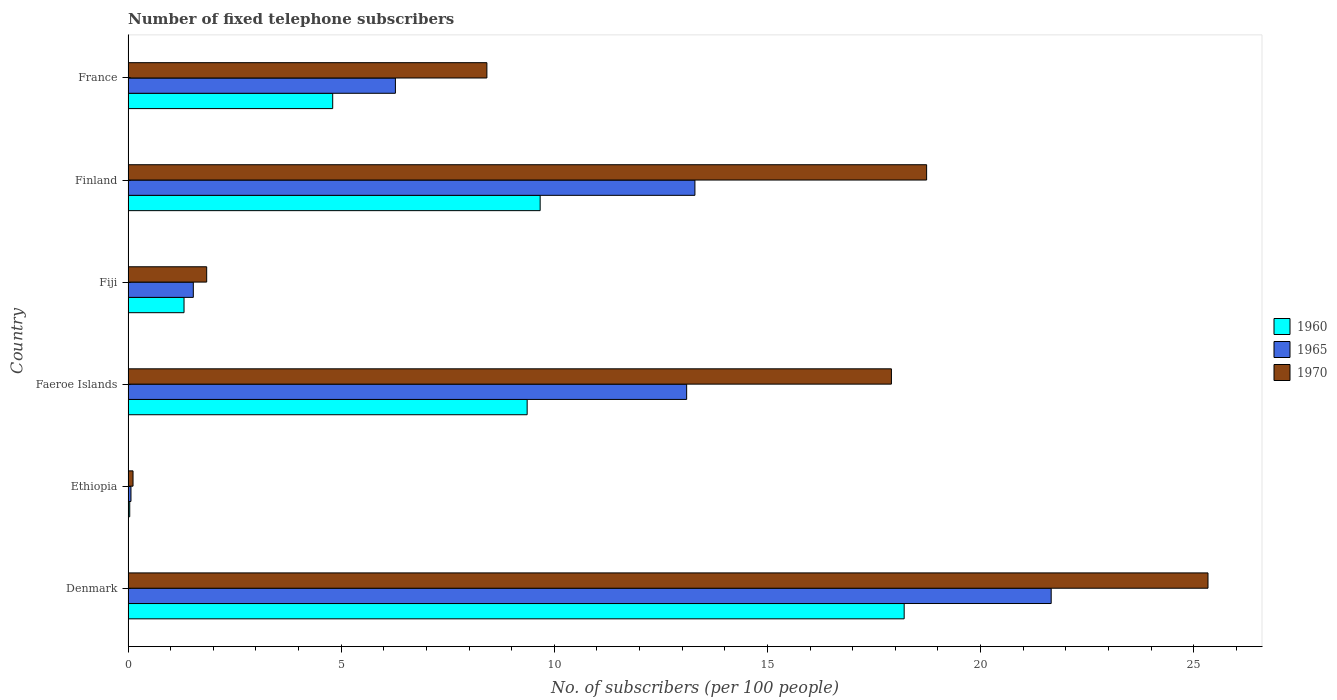How many different coloured bars are there?
Your answer should be very brief. 3. How many groups of bars are there?
Make the answer very short. 6. How many bars are there on the 4th tick from the bottom?
Your answer should be compact. 3. What is the label of the 1st group of bars from the top?
Ensure brevity in your answer.  France. What is the number of fixed telephone subscribers in 1965 in Denmark?
Provide a short and direct response. 21.66. Across all countries, what is the maximum number of fixed telephone subscribers in 1965?
Offer a terse response. 21.66. Across all countries, what is the minimum number of fixed telephone subscribers in 1965?
Your response must be concise. 0.07. In which country was the number of fixed telephone subscribers in 1965 minimum?
Provide a short and direct response. Ethiopia. What is the total number of fixed telephone subscribers in 1970 in the graph?
Ensure brevity in your answer.  72.35. What is the difference between the number of fixed telephone subscribers in 1960 in Finland and that in France?
Make the answer very short. 4.87. What is the difference between the number of fixed telephone subscribers in 1970 in France and the number of fixed telephone subscribers in 1965 in Finland?
Your answer should be very brief. -4.88. What is the average number of fixed telephone subscribers in 1965 per country?
Your answer should be very brief. 9.32. What is the difference between the number of fixed telephone subscribers in 1965 and number of fixed telephone subscribers in 1960 in Finland?
Ensure brevity in your answer.  3.63. What is the ratio of the number of fixed telephone subscribers in 1960 in Fiji to that in France?
Keep it short and to the point. 0.27. Is the difference between the number of fixed telephone subscribers in 1965 in Denmark and Finland greater than the difference between the number of fixed telephone subscribers in 1960 in Denmark and Finland?
Keep it short and to the point. No. What is the difference between the highest and the second highest number of fixed telephone subscribers in 1965?
Offer a terse response. 8.36. What is the difference between the highest and the lowest number of fixed telephone subscribers in 1965?
Offer a terse response. 21.59. In how many countries, is the number of fixed telephone subscribers in 1970 greater than the average number of fixed telephone subscribers in 1970 taken over all countries?
Ensure brevity in your answer.  3. What does the 2nd bar from the top in Fiji represents?
Keep it short and to the point. 1965. What does the 2nd bar from the bottom in Faeroe Islands represents?
Your response must be concise. 1965. How many countries are there in the graph?
Make the answer very short. 6. What is the difference between two consecutive major ticks on the X-axis?
Offer a very short reply. 5. Are the values on the major ticks of X-axis written in scientific E-notation?
Provide a short and direct response. No. Does the graph contain any zero values?
Your answer should be compact. No. Where does the legend appear in the graph?
Provide a succinct answer. Center right. How many legend labels are there?
Your answer should be compact. 3. What is the title of the graph?
Your answer should be very brief. Number of fixed telephone subscribers. Does "1981" appear as one of the legend labels in the graph?
Keep it short and to the point. No. What is the label or title of the X-axis?
Your answer should be compact. No. of subscribers (per 100 people). What is the No. of subscribers (per 100 people) in 1960 in Denmark?
Give a very brief answer. 18.21. What is the No. of subscribers (per 100 people) in 1965 in Denmark?
Provide a short and direct response. 21.66. What is the No. of subscribers (per 100 people) of 1970 in Denmark?
Your response must be concise. 25.33. What is the No. of subscribers (per 100 people) of 1960 in Ethiopia?
Offer a very short reply. 0.04. What is the No. of subscribers (per 100 people) of 1965 in Ethiopia?
Provide a succinct answer. 0.07. What is the No. of subscribers (per 100 people) of 1970 in Ethiopia?
Ensure brevity in your answer.  0.12. What is the No. of subscribers (per 100 people) of 1960 in Faeroe Islands?
Your answer should be compact. 9.36. What is the No. of subscribers (per 100 people) in 1965 in Faeroe Islands?
Make the answer very short. 13.1. What is the No. of subscribers (per 100 people) of 1970 in Faeroe Islands?
Keep it short and to the point. 17.91. What is the No. of subscribers (per 100 people) of 1960 in Fiji?
Your answer should be very brief. 1.31. What is the No. of subscribers (per 100 people) in 1965 in Fiji?
Ensure brevity in your answer.  1.53. What is the No. of subscribers (per 100 people) of 1970 in Fiji?
Make the answer very short. 1.84. What is the No. of subscribers (per 100 people) of 1960 in Finland?
Make the answer very short. 9.67. What is the No. of subscribers (per 100 people) in 1965 in Finland?
Your answer should be very brief. 13.3. What is the No. of subscribers (per 100 people) in 1970 in Finland?
Provide a succinct answer. 18.73. What is the No. of subscribers (per 100 people) of 1960 in France?
Your answer should be compact. 4.8. What is the No. of subscribers (per 100 people) of 1965 in France?
Offer a very short reply. 6.27. What is the No. of subscribers (per 100 people) of 1970 in France?
Offer a very short reply. 8.42. Across all countries, what is the maximum No. of subscribers (per 100 people) in 1960?
Make the answer very short. 18.21. Across all countries, what is the maximum No. of subscribers (per 100 people) of 1965?
Your answer should be very brief. 21.66. Across all countries, what is the maximum No. of subscribers (per 100 people) of 1970?
Make the answer very short. 25.33. Across all countries, what is the minimum No. of subscribers (per 100 people) of 1960?
Your answer should be compact. 0.04. Across all countries, what is the minimum No. of subscribers (per 100 people) of 1965?
Your answer should be very brief. 0.07. Across all countries, what is the minimum No. of subscribers (per 100 people) in 1970?
Give a very brief answer. 0.12. What is the total No. of subscribers (per 100 people) of 1960 in the graph?
Ensure brevity in your answer.  43.39. What is the total No. of subscribers (per 100 people) of 1965 in the graph?
Keep it short and to the point. 55.93. What is the total No. of subscribers (per 100 people) in 1970 in the graph?
Keep it short and to the point. 72.35. What is the difference between the No. of subscribers (per 100 people) in 1960 in Denmark and that in Ethiopia?
Provide a succinct answer. 18.17. What is the difference between the No. of subscribers (per 100 people) in 1965 in Denmark and that in Ethiopia?
Make the answer very short. 21.59. What is the difference between the No. of subscribers (per 100 people) in 1970 in Denmark and that in Ethiopia?
Keep it short and to the point. 25.22. What is the difference between the No. of subscribers (per 100 people) of 1960 in Denmark and that in Faeroe Islands?
Provide a short and direct response. 8.84. What is the difference between the No. of subscribers (per 100 people) of 1965 in Denmark and that in Faeroe Islands?
Give a very brief answer. 8.55. What is the difference between the No. of subscribers (per 100 people) in 1970 in Denmark and that in Faeroe Islands?
Ensure brevity in your answer.  7.43. What is the difference between the No. of subscribers (per 100 people) of 1960 in Denmark and that in Fiji?
Offer a very short reply. 16.89. What is the difference between the No. of subscribers (per 100 people) of 1965 in Denmark and that in Fiji?
Offer a very short reply. 20.13. What is the difference between the No. of subscribers (per 100 people) in 1970 in Denmark and that in Fiji?
Provide a succinct answer. 23.49. What is the difference between the No. of subscribers (per 100 people) of 1960 in Denmark and that in Finland?
Keep it short and to the point. 8.54. What is the difference between the No. of subscribers (per 100 people) of 1965 in Denmark and that in Finland?
Provide a short and direct response. 8.36. What is the difference between the No. of subscribers (per 100 people) in 1970 in Denmark and that in Finland?
Your response must be concise. 6.6. What is the difference between the No. of subscribers (per 100 people) in 1960 in Denmark and that in France?
Make the answer very short. 13.41. What is the difference between the No. of subscribers (per 100 people) of 1965 in Denmark and that in France?
Offer a very short reply. 15.38. What is the difference between the No. of subscribers (per 100 people) of 1970 in Denmark and that in France?
Your answer should be compact. 16.92. What is the difference between the No. of subscribers (per 100 people) of 1960 in Ethiopia and that in Faeroe Islands?
Provide a succinct answer. -9.32. What is the difference between the No. of subscribers (per 100 people) of 1965 in Ethiopia and that in Faeroe Islands?
Keep it short and to the point. -13.04. What is the difference between the No. of subscribers (per 100 people) of 1970 in Ethiopia and that in Faeroe Islands?
Your response must be concise. -17.79. What is the difference between the No. of subscribers (per 100 people) in 1960 in Ethiopia and that in Fiji?
Your answer should be compact. -1.27. What is the difference between the No. of subscribers (per 100 people) of 1965 in Ethiopia and that in Fiji?
Ensure brevity in your answer.  -1.46. What is the difference between the No. of subscribers (per 100 people) of 1970 in Ethiopia and that in Fiji?
Your answer should be compact. -1.73. What is the difference between the No. of subscribers (per 100 people) in 1960 in Ethiopia and that in Finland?
Give a very brief answer. -9.63. What is the difference between the No. of subscribers (per 100 people) of 1965 in Ethiopia and that in Finland?
Offer a terse response. -13.23. What is the difference between the No. of subscribers (per 100 people) of 1970 in Ethiopia and that in Finland?
Give a very brief answer. -18.62. What is the difference between the No. of subscribers (per 100 people) of 1960 in Ethiopia and that in France?
Give a very brief answer. -4.76. What is the difference between the No. of subscribers (per 100 people) in 1965 in Ethiopia and that in France?
Ensure brevity in your answer.  -6.2. What is the difference between the No. of subscribers (per 100 people) of 1970 in Ethiopia and that in France?
Ensure brevity in your answer.  -8.3. What is the difference between the No. of subscribers (per 100 people) of 1960 in Faeroe Islands and that in Fiji?
Ensure brevity in your answer.  8.05. What is the difference between the No. of subscribers (per 100 people) in 1965 in Faeroe Islands and that in Fiji?
Provide a short and direct response. 11.57. What is the difference between the No. of subscribers (per 100 people) in 1970 in Faeroe Islands and that in Fiji?
Make the answer very short. 16.06. What is the difference between the No. of subscribers (per 100 people) in 1960 in Faeroe Islands and that in Finland?
Provide a short and direct response. -0.31. What is the difference between the No. of subscribers (per 100 people) of 1965 in Faeroe Islands and that in Finland?
Offer a very short reply. -0.19. What is the difference between the No. of subscribers (per 100 people) in 1970 in Faeroe Islands and that in Finland?
Your answer should be compact. -0.83. What is the difference between the No. of subscribers (per 100 people) of 1960 in Faeroe Islands and that in France?
Offer a terse response. 4.56. What is the difference between the No. of subscribers (per 100 people) in 1965 in Faeroe Islands and that in France?
Your answer should be compact. 6.83. What is the difference between the No. of subscribers (per 100 people) in 1970 in Faeroe Islands and that in France?
Ensure brevity in your answer.  9.49. What is the difference between the No. of subscribers (per 100 people) of 1960 in Fiji and that in Finland?
Offer a terse response. -8.35. What is the difference between the No. of subscribers (per 100 people) of 1965 in Fiji and that in Finland?
Offer a terse response. -11.77. What is the difference between the No. of subscribers (per 100 people) in 1970 in Fiji and that in Finland?
Your answer should be compact. -16.89. What is the difference between the No. of subscribers (per 100 people) in 1960 in Fiji and that in France?
Offer a very short reply. -3.49. What is the difference between the No. of subscribers (per 100 people) in 1965 in Fiji and that in France?
Keep it short and to the point. -4.74. What is the difference between the No. of subscribers (per 100 people) in 1970 in Fiji and that in France?
Ensure brevity in your answer.  -6.57. What is the difference between the No. of subscribers (per 100 people) of 1960 in Finland and that in France?
Ensure brevity in your answer.  4.87. What is the difference between the No. of subscribers (per 100 people) of 1965 in Finland and that in France?
Your response must be concise. 7.03. What is the difference between the No. of subscribers (per 100 people) in 1970 in Finland and that in France?
Keep it short and to the point. 10.32. What is the difference between the No. of subscribers (per 100 people) in 1960 in Denmark and the No. of subscribers (per 100 people) in 1965 in Ethiopia?
Offer a very short reply. 18.14. What is the difference between the No. of subscribers (per 100 people) of 1960 in Denmark and the No. of subscribers (per 100 people) of 1970 in Ethiopia?
Ensure brevity in your answer.  18.09. What is the difference between the No. of subscribers (per 100 people) in 1965 in Denmark and the No. of subscribers (per 100 people) in 1970 in Ethiopia?
Give a very brief answer. 21.54. What is the difference between the No. of subscribers (per 100 people) in 1960 in Denmark and the No. of subscribers (per 100 people) in 1965 in Faeroe Islands?
Give a very brief answer. 5.1. What is the difference between the No. of subscribers (per 100 people) in 1960 in Denmark and the No. of subscribers (per 100 people) in 1970 in Faeroe Islands?
Offer a very short reply. 0.3. What is the difference between the No. of subscribers (per 100 people) in 1965 in Denmark and the No. of subscribers (per 100 people) in 1970 in Faeroe Islands?
Ensure brevity in your answer.  3.75. What is the difference between the No. of subscribers (per 100 people) in 1960 in Denmark and the No. of subscribers (per 100 people) in 1965 in Fiji?
Your answer should be compact. 16.68. What is the difference between the No. of subscribers (per 100 people) in 1960 in Denmark and the No. of subscribers (per 100 people) in 1970 in Fiji?
Keep it short and to the point. 16.36. What is the difference between the No. of subscribers (per 100 people) of 1965 in Denmark and the No. of subscribers (per 100 people) of 1970 in Fiji?
Your answer should be very brief. 19.81. What is the difference between the No. of subscribers (per 100 people) in 1960 in Denmark and the No. of subscribers (per 100 people) in 1965 in Finland?
Keep it short and to the point. 4.91. What is the difference between the No. of subscribers (per 100 people) in 1960 in Denmark and the No. of subscribers (per 100 people) in 1970 in Finland?
Provide a succinct answer. -0.53. What is the difference between the No. of subscribers (per 100 people) of 1965 in Denmark and the No. of subscribers (per 100 people) of 1970 in Finland?
Your response must be concise. 2.92. What is the difference between the No. of subscribers (per 100 people) of 1960 in Denmark and the No. of subscribers (per 100 people) of 1965 in France?
Offer a terse response. 11.94. What is the difference between the No. of subscribers (per 100 people) of 1960 in Denmark and the No. of subscribers (per 100 people) of 1970 in France?
Make the answer very short. 9.79. What is the difference between the No. of subscribers (per 100 people) in 1965 in Denmark and the No. of subscribers (per 100 people) in 1970 in France?
Offer a terse response. 13.24. What is the difference between the No. of subscribers (per 100 people) in 1960 in Ethiopia and the No. of subscribers (per 100 people) in 1965 in Faeroe Islands?
Offer a very short reply. -13.06. What is the difference between the No. of subscribers (per 100 people) of 1960 in Ethiopia and the No. of subscribers (per 100 people) of 1970 in Faeroe Islands?
Your response must be concise. -17.87. What is the difference between the No. of subscribers (per 100 people) of 1965 in Ethiopia and the No. of subscribers (per 100 people) of 1970 in Faeroe Islands?
Provide a short and direct response. -17.84. What is the difference between the No. of subscribers (per 100 people) of 1960 in Ethiopia and the No. of subscribers (per 100 people) of 1965 in Fiji?
Ensure brevity in your answer.  -1.49. What is the difference between the No. of subscribers (per 100 people) of 1960 in Ethiopia and the No. of subscribers (per 100 people) of 1970 in Fiji?
Offer a terse response. -1.81. What is the difference between the No. of subscribers (per 100 people) in 1965 in Ethiopia and the No. of subscribers (per 100 people) in 1970 in Fiji?
Your answer should be very brief. -1.78. What is the difference between the No. of subscribers (per 100 people) in 1960 in Ethiopia and the No. of subscribers (per 100 people) in 1965 in Finland?
Your response must be concise. -13.26. What is the difference between the No. of subscribers (per 100 people) in 1960 in Ethiopia and the No. of subscribers (per 100 people) in 1970 in Finland?
Offer a very short reply. -18.69. What is the difference between the No. of subscribers (per 100 people) of 1965 in Ethiopia and the No. of subscribers (per 100 people) of 1970 in Finland?
Ensure brevity in your answer.  -18.67. What is the difference between the No. of subscribers (per 100 people) in 1960 in Ethiopia and the No. of subscribers (per 100 people) in 1965 in France?
Your response must be concise. -6.23. What is the difference between the No. of subscribers (per 100 people) of 1960 in Ethiopia and the No. of subscribers (per 100 people) of 1970 in France?
Your answer should be compact. -8.38. What is the difference between the No. of subscribers (per 100 people) of 1965 in Ethiopia and the No. of subscribers (per 100 people) of 1970 in France?
Provide a succinct answer. -8.35. What is the difference between the No. of subscribers (per 100 people) in 1960 in Faeroe Islands and the No. of subscribers (per 100 people) in 1965 in Fiji?
Ensure brevity in your answer.  7.83. What is the difference between the No. of subscribers (per 100 people) of 1960 in Faeroe Islands and the No. of subscribers (per 100 people) of 1970 in Fiji?
Provide a short and direct response. 7.52. What is the difference between the No. of subscribers (per 100 people) of 1965 in Faeroe Islands and the No. of subscribers (per 100 people) of 1970 in Fiji?
Your answer should be very brief. 11.26. What is the difference between the No. of subscribers (per 100 people) of 1960 in Faeroe Islands and the No. of subscribers (per 100 people) of 1965 in Finland?
Provide a succinct answer. -3.94. What is the difference between the No. of subscribers (per 100 people) in 1960 in Faeroe Islands and the No. of subscribers (per 100 people) in 1970 in Finland?
Your answer should be very brief. -9.37. What is the difference between the No. of subscribers (per 100 people) in 1965 in Faeroe Islands and the No. of subscribers (per 100 people) in 1970 in Finland?
Make the answer very short. -5.63. What is the difference between the No. of subscribers (per 100 people) of 1960 in Faeroe Islands and the No. of subscribers (per 100 people) of 1965 in France?
Ensure brevity in your answer.  3.09. What is the difference between the No. of subscribers (per 100 people) in 1960 in Faeroe Islands and the No. of subscribers (per 100 people) in 1970 in France?
Provide a succinct answer. 0.94. What is the difference between the No. of subscribers (per 100 people) of 1965 in Faeroe Islands and the No. of subscribers (per 100 people) of 1970 in France?
Offer a very short reply. 4.69. What is the difference between the No. of subscribers (per 100 people) in 1960 in Fiji and the No. of subscribers (per 100 people) in 1965 in Finland?
Provide a succinct answer. -11.98. What is the difference between the No. of subscribers (per 100 people) of 1960 in Fiji and the No. of subscribers (per 100 people) of 1970 in Finland?
Your answer should be compact. -17.42. What is the difference between the No. of subscribers (per 100 people) of 1965 in Fiji and the No. of subscribers (per 100 people) of 1970 in Finland?
Make the answer very short. -17.2. What is the difference between the No. of subscribers (per 100 people) of 1960 in Fiji and the No. of subscribers (per 100 people) of 1965 in France?
Offer a very short reply. -4.96. What is the difference between the No. of subscribers (per 100 people) in 1960 in Fiji and the No. of subscribers (per 100 people) in 1970 in France?
Ensure brevity in your answer.  -7.1. What is the difference between the No. of subscribers (per 100 people) in 1965 in Fiji and the No. of subscribers (per 100 people) in 1970 in France?
Provide a short and direct response. -6.89. What is the difference between the No. of subscribers (per 100 people) of 1960 in Finland and the No. of subscribers (per 100 people) of 1965 in France?
Your response must be concise. 3.4. What is the difference between the No. of subscribers (per 100 people) in 1960 in Finland and the No. of subscribers (per 100 people) in 1970 in France?
Give a very brief answer. 1.25. What is the difference between the No. of subscribers (per 100 people) in 1965 in Finland and the No. of subscribers (per 100 people) in 1970 in France?
Your response must be concise. 4.88. What is the average No. of subscribers (per 100 people) in 1960 per country?
Make the answer very short. 7.23. What is the average No. of subscribers (per 100 people) in 1965 per country?
Ensure brevity in your answer.  9.32. What is the average No. of subscribers (per 100 people) of 1970 per country?
Keep it short and to the point. 12.06. What is the difference between the No. of subscribers (per 100 people) in 1960 and No. of subscribers (per 100 people) in 1965 in Denmark?
Ensure brevity in your answer.  -3.45. What is the difference between the No. of subscribers (per 100 people) of 1960 and No. of subscribers (per 100 people) of 1970 in Denmark?
Provide a short and direct response. -7.13. What is the difference between the No. of subscribers (per 100 people) of 1965 and No. of subscribers (per 100 people) of 1970 in Denmark?
Make the answer very short. -3.68. What is the difference between the No. of subscribers (per 100 people) of 1960 and No. of subscribers (per 100 people) of 1965 in Ethiopia?
Your response must be concise. -0.03. What is the difference between the No. of subscribers (per 100 people) in 1960 and No. of subscribers (per 100 people) in 1970 in Ethiopia?
Provide a short and direct response. -0.08. What is the difference between the No. of subscribers (per 100 people) in 1965 and No. of subscribers (per 100 people) in 1970 in Ethiopia?
Provide a succinct answer. -0.05. What is the difference between the No. of subscribers (per 100 people) of 1960 and No. of subscribers (per 100 people) of 1965 in Faeroe Islands?
Your answer should be compact. -3.74. What is the difference between the No. of subscribers (per 100 people) in 1960 and No. of subscribers (per 100 people) in 1970 in Faeroe Islands?
Your answer should be very brief. -8.55. What is the difference between the No. of subscribers (per 100 people) in 1965 and No. of subscribers (per 100 people) in 1970 in Faeroe Islands?
Offer a terse response. -4.8. What is the difference between the No. of subscribers (per 100 people) in 1960 and No. of subscribers (per 100 people) in 1965 in Fiji?
Your response must be concise. -0.22. What is the difference between the No. of subscribers (per 100 people) in 1960 and No. of subscribers (per 100 people) in 1970 in Fiji?
Ensure brevity in your answer.  -0.53. What is the difference between the No. of subscribers (per 100 people) in 1965 and No. of subscribers (per 100 people) in 1970 in Fiji?
Your answer should be very brief. -0.31. What is the difference between the No. of subscribers (per 100 people) in 1960 and No. of subscribers (per 100 people) in 1965 in Finland?
Your answer should be compact. -3.63. What is the difference between the No. of subscribers (per 100 people) in 1960 and No. of subscribers (per 100 people) in 1970 in Finland?
Offer a very short reply. -9.07. What is the difference between the No. of subscribers (per 100 people) of 1965 and No. of subscribers (per 100 people) of 1970 in Finland?
Your answer should be very brief. -5.44. What is the difference between the No. of subscribers (per 100 people) of 1960 and No. of subscribers (per 100 people) of 1965 in France?
Your answer should be very brief. -1.47. What is the difference between the No. of subscribers (per 100 people) in 1960 and No. of subscribers (per 100 people) in 1970 in France?
Provide a short and direct response. -3.62. What is the difference between the No. of subscribers (per 100 people) in 1965 and No. of subscribers (per 100 people) in 1970 in France?
Provide a succinct answer. -2.15. What is the ratio of the No. of subscribers (per 100 people) of 1960 in Denmark to that in Ethiopia?
Your answer should be compact. 466.99. What is the ratio of the No. of subscribers (per 100 people) in 1965 in Denmark to that in Ethiopia?
Keep it short and to the point. 318.64. What is the ratio of the No. of subscribers (per 100 people) of 1970 in Denmark to that in Ethiopia?
Provide a succinct answer. 218.14. What is the ratio of the No. of subscribers (per 100 people) of 1960 in Denmark to that in Faeroe Islands?
Ensure brevity in your answer.  1.94. What is the ratio of the No. of subscribers (per 100 people) in 1965 in Denmark to that in Faeroe Islands?
Ensure brevity in your answer.  1.65. What is the ratio of the No. of subscribers (per 100 people) of 1970 in Denmark to that in Faeroe Islands?
Your response must be concise. 1.41. What is the ratio of the No. of subscribers (per 100 people) of 1960 in Denmark to that in Fiji?
Your answer should be compact. 13.87. What is the ratio of the No. of subscribers (per 100 people) in 1965 in Denmark to that in Fiji?
Your response must be concise. 14.15. What is the ratio of the No. of subscribers (per 100 people) of 1970 in Denmark to that in Fiji?
Offer a very short reply. 13.74. What is the ratio of the No. of subscribers (per 100 people) of 1960 in Denmark to that in Finland?
Offer a very short reply. 1.88. What is the ratio of the No. of subscribers (per 100 people) of 1965 in Denmark to that in Finland?
Your response must be concise. 1.63. What is the ratio of the No. of subscribers (per 100 people) of 1970 in Denmark to that in Finland?
Your answer should be compact. 1.35. What is the ratio of the No. of subscribers (per 100 people) in 1960 in Denmark to that in France?
Provide a succinct answer. 3.79. What is the ratio of the No. of subscribers (per 100 people) of 1965 in Denmark to that in France?
Offer a very short reply. 3.45. What is the ratio of the No. of subscribers (per 100 people) in 1970 in Denmark to that in France?
Ensure brevity in your answer.  3.01. What is the ratio of the No. of subscribers (per 100 people) of 1960 in Ethiopia to that in Faeroe Islands?
Ensure brevity in your answer.  0. What is the ratio of the No. of subscribers (per 100 people) of 1965 in Ethiopia to that in Faeroe Islands?
Keep it short and to the point. 0.01. What is the ratio of the No. of subscribers (per 100 people) of 1970 in Ethiopia to that in Faeroe Islands?
Your answer should be very brief. 0.01. What is the ratio of the No. of subscribers (per 100 people) in 1960 in Ethiopia to that in Fiji?
Give a very brief answer. 0.03. What is the ratio of the No. of subscribers (per 100 people) of 1965 in Ethiopia to that in Fiji?
Keep it short and to the point. 0.04. What is the ratio of the No. of subscribers (per 100 people) in 1970 in Ethiopia to that in Fiji?
Keep it short and to the point. 0.06. What is the ratio of the No. of subscribers (per 100 people) in 1960 in Ethiopia to that in Finland?
Make the answer very short. 0. What is the ratio of the No. of subscribers (per 100 people) of 1965 in Ethiopia to that in Finland?
Keep it short and to the point. 0.01. What is the ratio of the No. of subscribers (per 100 people) of 1970 in Ethiopia to that in Finland?
Ensure brevity in your answer.  0.01. What is the ratio of the No. of subscribers (per 100 people) in 1960 in Ethiopia to that in France?
Offer a very short reply. 0.01. What is the ratio of the No. of subscribers (per 100 people) in 1965 in Ethiopia to that in France?
Give a very brief answer. 0.01. What is the ratio of the No. of subscribers (per 100 people) of 1970 in Ethiopia to that in France?
Provide a succinct answer. 0.01. What is the ratio of the No. of subscribers (per 100 people) in 1960 in Faeroe Islands to that in Fiji?
Keep it short and to the point. 7.13. What is the ratio of the No. of subscribers (per 100 people) of 1965 in Faeroe Islands to that in Fiji?
Provide a short and direct response. 8.56. What is the ratio of the No. of subscribers (per 100 people) of 1970 in Faeroe Islands to that in Fiji?
Make the answer very short. 9.71. What is the ratio of the No. of subscribers (per 100 people) in 1960 in Faeroe Islands to that in Finland?
Your answer should be very brief. 0.97. What is the ratio of the No. of subscribers (per 100 people) in 1965 in Faeroe Islands to that in Finland?
Make the answer very short. 0.99. What is the ratio of the No. of subscribers (per 100 people) of 1970 in Faeroe Islands to that in Finland?
Ensure brevity in your answer.  0.96. What is the ratio of the No. of subscribers (per 100 people) in 1960 in Faeroe Islands to that in France?
Offer a terse response. 1.95. What is the ratio of the No. of subscribers (per 100 people) in 1965 in Faeroe Islands to that in France?
Your response must be concise. 2.09. What is the ratio of the No. of subscribers (per 100 people) in 1970 in Faeroe Islands to that in France?
Make the answer very short. 2.13. What is the ratio of the No. of subscribers (per 100 people) of 1960 in Fiji to that in Finland?
Ensure brevity in your answer.  0.14. What is the ratio of the No. of subscribers (per 100 people) in 1965 in Fiji to that in Finland?
Give a very brief answer. 0.12. What is the ratio of the No. of subscribers (per 100 people) in 1970 in Fiji to that in Finland?
Your answer should be compact. 0.1. What is the ratio of the No. of subscribers (per 100 people) of 1960 in Fiji to that in France?
Keep it short and to the point. 0.27. What is the ratio of the No. of subscribers (per 100 people) of 1965 in Fiji to that in France?
Your response must be concise. 0.24. What is the ratio of the No. of subscribers (per 100 people) of 1970 in Fiji to that in France?
Keep it short and to the point. 0.22. What is the ratio of the No. of subscribers (per 100 people) of 1960 in Finland to that in France?
Ensure brevity in your answer.  2.01. What is the ratio of the No. of subscribers (per 100 people) of 1965 in Finland to that in France?
Your answer should be compact. 2.12. What is the ratio of the No. of subscribers (per 100 people) in 1970 in Finland to that in France?
Keep it short and to the point. 2.23. What is the difference between the highest and the second highest No. of subscribers (per 100 people) of 1960?
Provide a succinct answer. 8.54. What is the difference between the highest and the second highest No. of subscribers (per 100 people) of 1965?
Offer a terse response. 8.36. What is the difference between the highest and the second highest No. of subscribers (per 100 people) in 1970?
Give a very brief answer. 6.6. What is the difference between the highest and the lowest No. of subscribers (per 100 people) of 1960?
Offer a terse response. 18.17. What is the difference between the highest and the lowest No. of subscribers (per 100 people) in 1965?
Your answer should be very brief. 21.59. What is the difference between the highest and the lowest No. of subscribers (per 100 people) in 1970?
Offer a terse response. 25.22. 